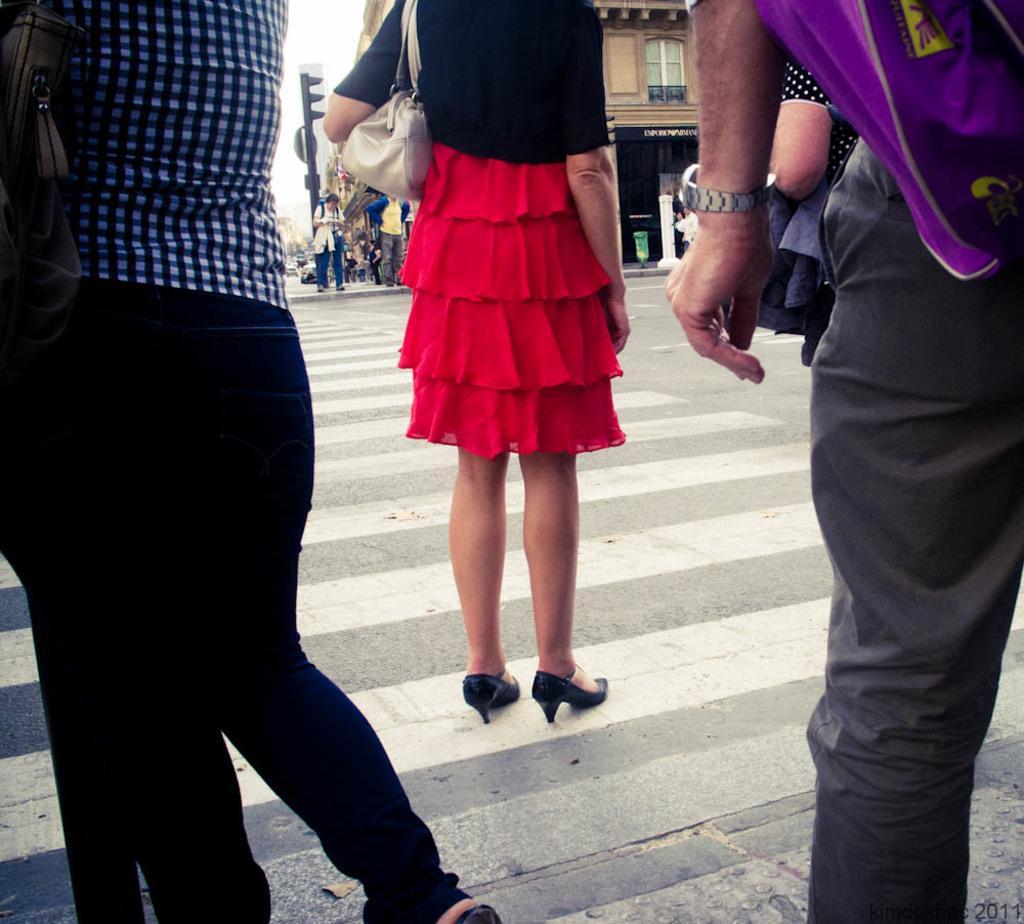Can you describe this image briefly? This is the picture of a road. In the foreground there are three persons standing on the road. At the back there are group of people standing on the footpath and there is a pole on the footpath. At the back there are buildings. At the top there is sky. At the bottom there is a road. 